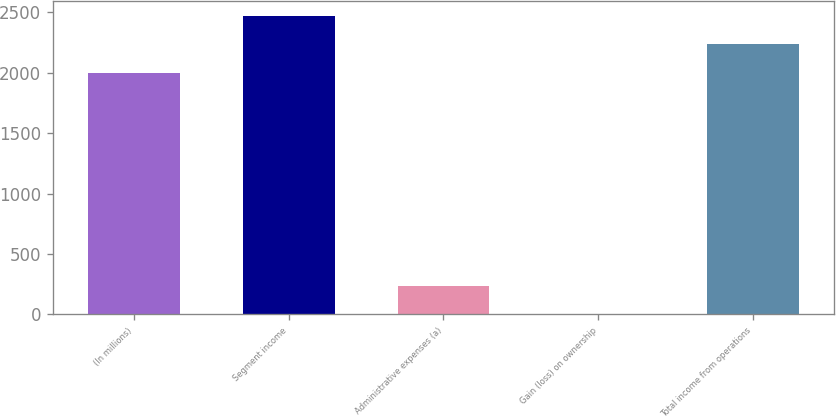Convert chart to OTSL. <chart><loc_0><loc_0><loc_500><loc_500><bar_chart><fcel>(In millions)<fcel>Segment income<fcel>Administrative expenses (a)<fcel>Gain (loss) on ownership<fcel>Total income from operations<nl><fcel>2003<fcel>2468.8<fcel>233.9<fcel>1<fcel>2235.9<nl></chart> 